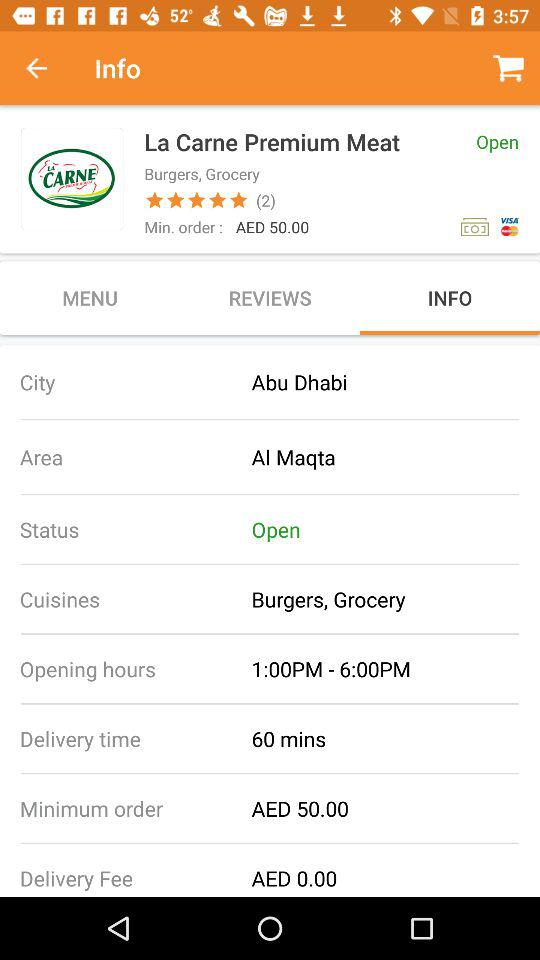How much does it cost to place a minimum order? The cost to place a minimum order is 50 AED. 